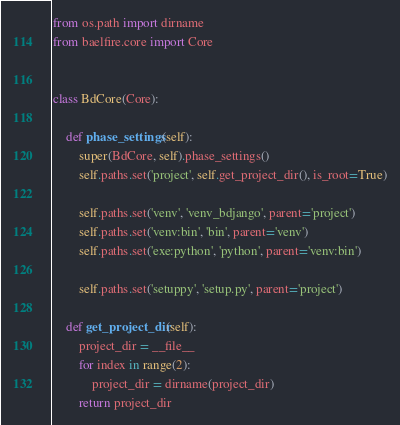<code> <loc_0><loc_0><loc_500><loc_500><_Python_>from os.path import dirname
from baelfire.core import Core


class BdCore(Core):

    def phase_settings(self):
        super(BdCore, self).phase_settings()
        self.paths.set('project', self.get_project_dir(), is_root=True)

        self.paths.set('venv', 'venv_bdjango', parent='project')
        self.paths.set('venv:bin', 'bin', parent='venv')
        self.paths.set('exe:python', 'python', parent='venv:bin')

        self.paths.set('setuppy', 'setup.py', parent='project')

    def get_project_dir(self):
        project_dir = __file__
        for index in range(2):
            project_dir = dirname(project_dir)
        return project_dir
</code> 